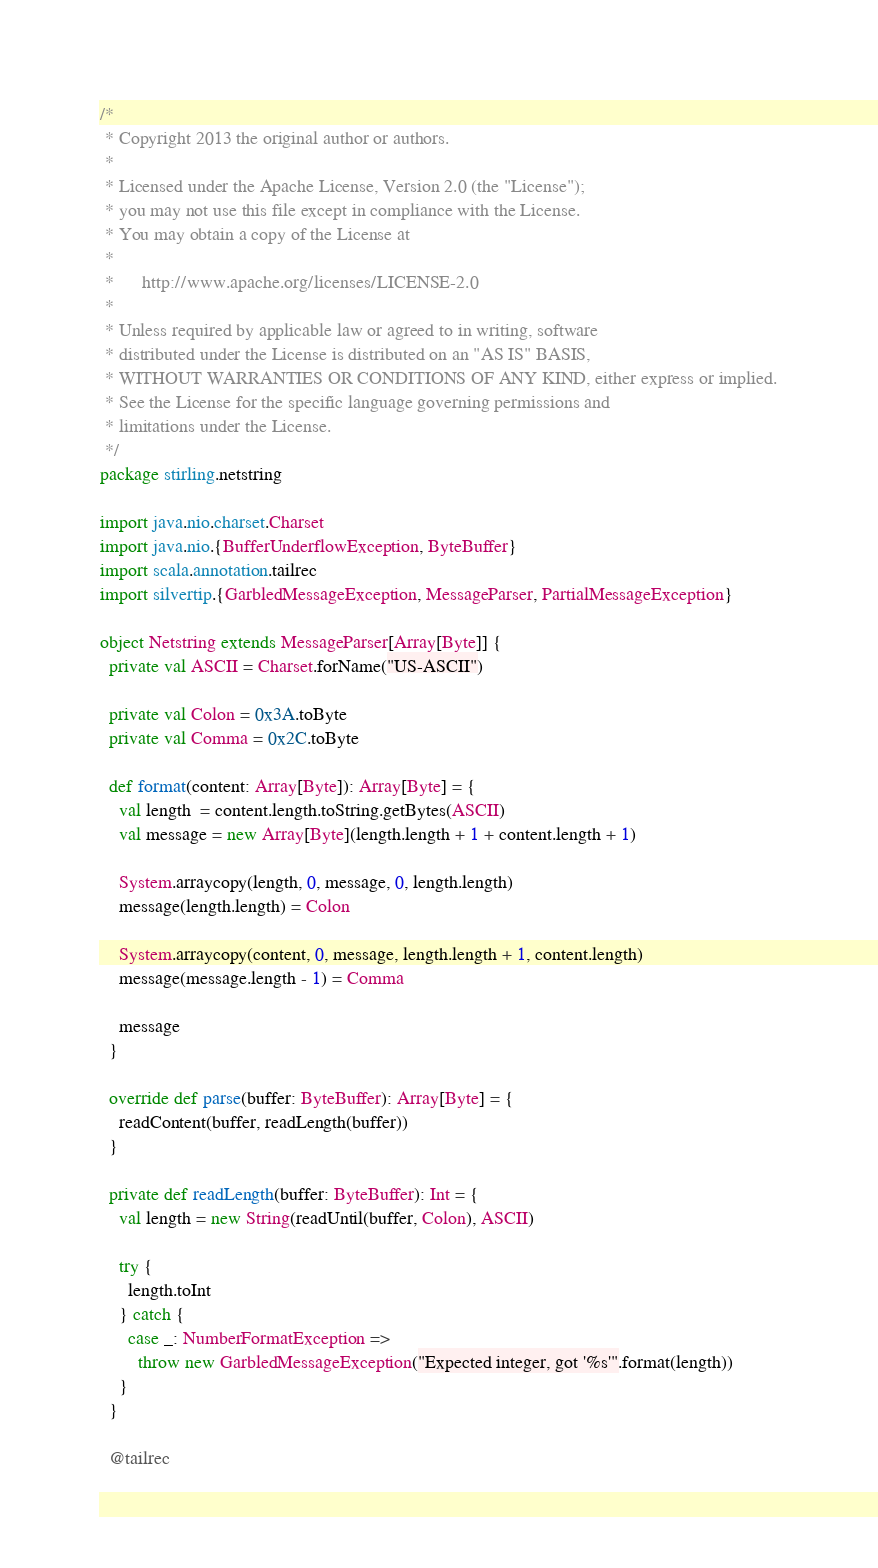Convert code to text. <code><loc_0><loc_0><loc_500><loc_500><_Scala_>/*
 * Copyright 2013 the original author or authors.
 *
 * Licensed under the Apache License, Version 2.0 (the "License");
 * you may not use this file except in compliance with the License.
 * You may obtain a copy of the License at
 *
 *      http://www.apache.org/licenses/LICENSE-2.0
 *
 * Unless required by applicable law or agreed to in writing, software
 * distributed under the License is distributed on an "AS IS" BASIS,
 * WITHOUT WARRANTIES OR CONDITIONS OF ANY KIND, either express or implied.
 * See the License for the specific language governing permissions and
 * limitations under the License.
 */
package stirling.netstring

import java.nio.charset.Charset
import java.nio.{BufferUnderflowException, ByteBuffer}
import scala.annotation.tailrec
import silvertip.{GarbledMessageException, MessageParser, PartialMessageException}

object Netstring extends MessageParser[Array[Byte]] {
  private val ASCII = Charset.forName("US-ASCII")

  private val Colon = 0x3A.toByte
  private val Comma = 0x2C.toByte

  def format(content: Array[Byte]): Array[Byte] = {
    val length  = content.length.toString.getBytes(ASCII)
    val message = new Array[Byte](length.length + 1 + content.length + 1)

    System.arraycopy(length, 0, message, 0, length.length)
    message(length.length) = Colon

    System.arraycopy(content, 0, message, length.length + 1, content.length)
    message(message.length - 1) = Comma

    message
  }

  override def parse(buffer: ByteBuffer): Array[Byte] = {
    readContent(buffer, readLength(buffer))
  }

  private def readLength(buffer: ByteBuffer): Int = {
    val length = new String(readUntil(buffer, Colon), ASCII)

    try {
      length.toInt
    } catch {
      case _: NumberFormatException =>
        throw new GarbledMessageException("Expected integer, got '%s'".format(length))
    }
  }

  @tailrec</code> 